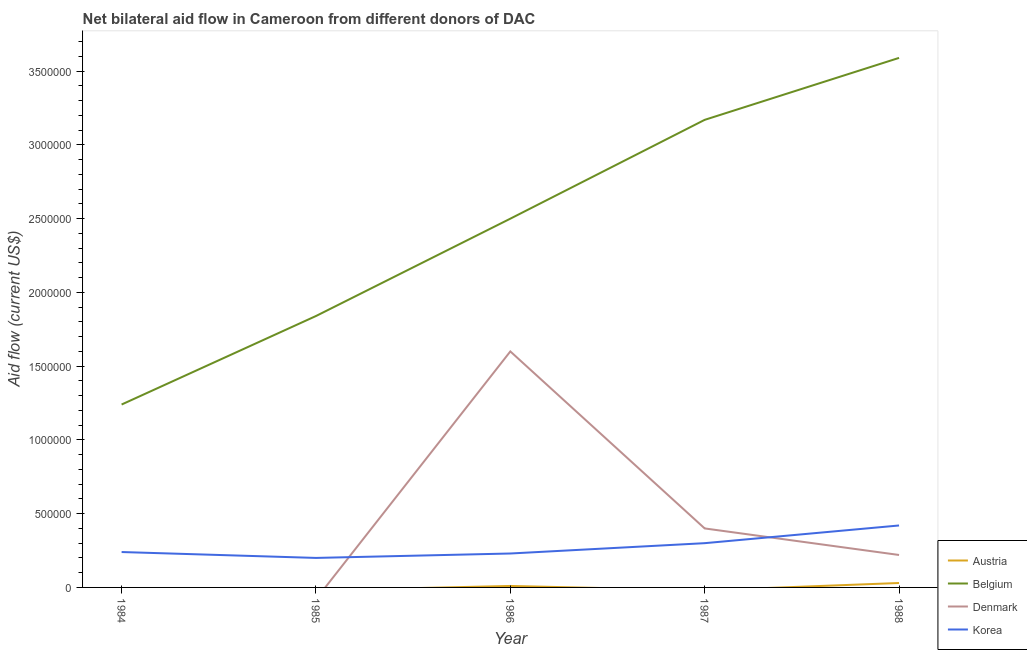Is the number of lines equal to the number of legend labels?
Offer a terse response. No. What is the amount of aid given by korea in 1985?
Your answer should be very brief. 2.00e+05. Across all years, what is the maximum amount of aid given by korea?
Your answer should be very brief. 4.20e+05. Across all years, what is the minimum amount of aid given by austria?
Your answer should be compact. 0. In which year was the amount of aid given by belgium maximum?
Give a very brief answer. 1988. What is the total amount of aid given by korea in the graph?
Your answer should be compact. 1.39e+06. What is the difference between the amount of aid given by korea in 1985 and that in 1986?
Ensure brevity in your answer.  -3.00e+04. What is the difference between the amount of aid given by austria in 1984 and the amount of aid given by denmark in 1988?
Ensure brevity in your answer.  -2.20e+05. What is the average amount of aid given by belgium per year?
Offer a very short reply. 2.47e+06. In the year 1986, what is the difference between the amount of aid given by korea and amount of aid given by austria?
Provide a short and direct response. 2.20e+05. What is the ratio of the amount of aid given by korea in 1986 to that in 1987?
Your answer should be compact. 0.77. Is the amount of aid given by denmark in 1986 less than that in 1987?
Your answer should be compact. No. What is the difference between the highest and the second highest amount of aid given by belgium?
Give a very brief answer. 4.20e+05. What is the difference between the highest and the lowest amount of aid given by korea?
Your response must be concise. 2.20e+05. Is the sum of the amount of aid given by korea in 1984 and 1988 greater than the maximum amount of aid given by austria across all years?
Offer a terse response. Yes. Is it the case that in every year, the sum of the amount of aid given by denmark and amount of aid given by korea is greater than the sum of amount of aid given by austria and amount of aid given by belgium?
Your answer should be compact. No. Does the amount of aid given by belgium monotonically increase over the years?
Offer a terse response. Yes. Is the amount of aid given by austria strictly greater than the amount of aid given by denmark over the years?
Your answer should be compact. No. Is the amount of aid given by austria strictly less than the amount of aid given by denmark over the years?
Your answer should be compact. No. How many years are there in the graph?
Keep it short and to the point. 5. Does the graph contain grids?
Offer a terse response. No. Where does the legend appear in the graph?
Make the answer very short. Bottom right. How many legend labels are there?
Your answer should be compact. 4. How are the legend labels stacked?
Make the answer very short. Vertical. What is the title of the graph?
Offer a terse response. Net bilateral aid flow in Cameroon from different donors of DAC. What is the label or title of the X-axis?
Your response must be concise. Year. What is the label or title of the Y-axis?
Your response must be concise. Aid flow (current US$). What is the Aid flow (current US$) in Austria in 1984?
Your response must be concise. 0. What is the Aid flow (current US$) of Belgium in 1984?
Your answer should be very brief. 1.24e+06. What is the Aid flow (current US$) of Korea in 1984?
Your answer should be very brief. 2.40e+05. What is the Aid flow (current US$) in Austria in 1985?
Your response must be concise. 0. What is the Aid flow (current US$) of Belgium in 1985?
Your answer should be compact. 1.84e+06. What is the Aid flow (current US$) in Austria in 1986?
Make the answer very short. 10000. What is the Aid flow (current US$) in Belgium in 1986?
Your answer should be very brief. 2.50e+06. What is the Aid flow (current US$) in Denmark in 1986?
Provide a succinct answer. 1.60e+06. What is the Aid flow (current US$) in Austria in 1987?
Your answer should be compact. 0. What is the Aid flow (current US$) in Belgium in 1987?
Give a very brief answer. 3.17e+06. What is the Aid flow (current US$) of Denmark in 1987?
Your response must be concise. 4.00e+05. What is the Aid flow (current US$) of Korea in 1987?
Provide a short and direct response. 3.00e+05. What is the Aid flow (current US$) in Austria in 1988?
Provide a succinct answer. 3.00e+04. What is the Aid flow (current US$) of Belgium in 1988?
Your response must be concise. 3.59e+06. What is the Aid flow (current US$) of Denmark in 1988?
Offer a very short reply. 2.20e+05. Across all years, what is the maximum Aid flow (current US$) in Belgium?
Your answer should be compact. 3.59e+06. Across all years, what is the maximum Aid flow (current US$) in Denmark?
Provide a short and direct response. 1.60e+06. Across all years, what is the minimum Aid flow (current US$) in Belgium?
Provide a succinct answer. 1.24e+06. Across all years, what is the minimum Aid flow (current US$) of Denmark?
Your answer should be compact. 0. What is the total Aid flow (current US$) in Belgium in the graph?
Your answer should be very brief. 1.23e+07. What is the total Aid flow (current US$) in Denmark in the graph?
Offer a terse response. 2.22e+06. What is the total Aid flow (current US$) of Korea in the graph?
Give a very brief answer. 1.39e+06. What is the difference between the Aid flow (current US$) of Belgium in 1984 and that in 1985?
Offer a very short reply. -6.00e+05. What is the difference between the Aid flow (current US$) in Belgium in 1984 and that in 1986?
Provide a short and direct response. -1.26e+06. What is the difference between the Aid flow (current US$) in Belgium in 1984 and that in 1987?
Provide a succinct answer. -1.93e+06. What is the difference between the Aid flow (current US$) in Belgium in 1984 and that in 1988?
Your answer should be very brief. -2.35e+06. What is the difference between the Aid flow (current US$) of Belgium in 1985 and that in 1986?
Your answer should be very brief. -6.60e+05. What is the difference between the Aid flow (current US$) of Belgium in 1985 and that in 1987?
Your response must be concise. -1.33e+06. What is the difference between the Aid flow (current US$) in Korea in 1985 and that in 1987?
Offer a very short reply. -1.00e+05. What is the difference between the Aid flow (current US$) in Belgium in 1985 and that in 1988?
Make the answer very short. -1.75e+06. What is the difference between the Aid flow (current US$) in Belgium in 1986 and that in 1987?
Provide a succinct answer. -6.70e+05. What is the difference between the Aid flow (current US$) of Denmark in 1986 and that in 1987?
Your answer should be very brief. 1.20e+06. What is the difference between the Aid flow (current US$) of Korea in 1986 and that in 1987?
Provide a short and direct response. -7.00e+04. What is the difference between the Aid flow (current US$) of Austria in 1986 and that in 1988?
Offer a very short reply. -2.00e+04. What is the difference between the Aid flow (current US$) in Belgium in 1986 and that in 1988?
Offer a terse response. -1.09e+06. What is the difference between the Aid flow (current US$) of Denmark in 1986 and that in 1988?
Ensure brevity in your answer.  1.38e+06. What is the difference between the Aid flow (current US$) in Korea in 1986 and that in 1988?
Offer a very short reply. -1.90e+05. What is the difference between the Aid flow (current US$) in Belgium in 1987 and that in 1988?
Your answer should be compact. -4.20e+05. What is the difference between the Aid flow (current US$) in Denmark in 1987 and that in 1988?
Keep it short and to the point. 1.80e+05. What is the difference between the Aid flow (current US$) in Korea in 1987 and that in 1988?
Your answer should be very brief. -1.20e+05. What is the difference between the Aid flow (current US$) in Belgium in 1984 and the Aid flow (current US$) in Korea in 1985?
Offer a very short reply. 1.04e+06. What is the difference between the Aid flow (current US$) of Belgium in 1984 and the Aid flow (current US$) of Denmark in 1986?
Give a very brief answer. -3.60e+05. What is the difference between the Aid flow (current US$) in Belgium in 1984 and the Aid flow (current US$) in Korea in 1986?
Your answer should be compact. 1.01e+06. What is the difference between the Aid flow (current US$) in Belgium in 1984 and the Aid flow (current US$) in Denmark in 1987?
Provide a succinct answer. 8.40e+05. What is the difference between the Aid flow (current US$) in Belgium in 1984 and the Aid flow (current US$) in Korea in 1987?
Offer a very short reply. 9.40e+05. What is the difference between the Aid flow (current US$) in Belgium in 1984 and the Aid flow (current US$) in Denmark in 1988?
Make the answer very short. 1.02e+06. What is the difference between the Aid flow (current US$) of Belgium in 1984 and the Aid flow (current US$) of Korea in 1988?
Make the answer very short. 8.20e+05. What is the difference between the Aid flow (current US$) of Belgium in 1985 and the Aid flow (current US$) of Denmark in 1986?
Your response must be concise. 2.40e+05. What is the difference between the Aid flow (current US$) of Belgium in 1985 and the Aid flow (current US$) of Korea in 1986?
Your response must be concise. 1.61e+06. What is the difference between the Aid flow (current US$) of Belgium in 1985 and the Aid flow (current US$) of Denmark in 1987?
Make the answer very short. 1.44e+06. What is the difference between the Aid flow (current US$) of Belgium in 1985 and the Aid flow (current US$) of Korea in 1987?
Provide a succinct answer. 1.54e+06. What is the difference between the Aid flow (current US$) in Belgium in 1985 and the Aid flow (current US$) in Denmark in 1988?
Keep it short and to the point. 1.62e+06. What is the difference between the Aid flow (current US$) in Belgium in 1985 and the Aid flow (current US$) in Korea in 1988?
Make the answer very short. 1.42e+06. What is the difference between the Aid flow (current US$) in Austria in 1986 and the Aid flow (current US$) in Belgium in 1987?
Offer a terse response. -3.16e+06. What is the difference between the Aid flow (current US$) of Austria in 1986 and the Aid flow (current US$) of Denmark in 1987?
Keep it short and to the point. -3.90e+05. What is the difference between the Aid flow (current US$) in Belgium in 1986 and the Aid flow (current US$) in Denmark in 1987?
Offer a very short reply. 2.10e+06. What is the difference between the Aid flow (current US$) in Belgium in 1986 and the Aid flow (current US$) in Korea in 1987?
Ensure brevity in your answer.  2.20e+06. What is the difference between the Aid flow (current US$) in Denmark in 1986 and the Aid flow (current US$) in Korea in 1987?
Provide a succinct answer. 1.30e+06. What is the difference between the Aid flow (current US$) in Austria in 1986 and the Aid flow (current US$) in Belgium in 1988?
Offer a very short reply. -3.58e+06. What is the difference between the Aid flow (current US$) in Austria in 1986 and the Aid flow (current US$) in Denmark in 1988?
Your answer should be compact. -2.10e+05. What is the difference between the Aid flow (current US$) in Austria in 1986 and the Aid flow (current US$) in Korea in 1988?
Offer a terse response. -4.10e+05. What is the difference between the Aid flow (current US$) of Belgium in 1986 and the Aid flow (current US$) of Denmark in 1988?
Your answer should be very brief. 2.28e+06. What is the difference between the Aid flow (current US$) of Belgium in 1986 and the Aid flow (current US$) of Korea in 1988?
Give a very brief answer. 2.08e+06. What is the difference between the Aid flow (current US$) of Denmark in 1986 and the Aid flow (current US$) of Korea in 1988?
Your answer should be compact. 1.18e+06. What is the difference between the Aid flow (current US$) in Belgium in 1987 and the Aid flow (current US$) in Denmark in 1988?
Your response must be concise. 2.95e+06. What is the difference between the Aid flow (current US$) in Belgium in 1987 and the Aid flow (current US$) in Korea in 1988?
Provide a succinct answer. 2.75e+06. What is the difference between the Aid flow (current US$) in Denmark in 1987 and the Aid flow (current US$) in Korea in 1988?
Provide a succinct answer. -2.00e+04. What is the average Aid flow (current US$) in Austria per year?
Your response must be concise. 8000. What is the average Aid flow (current US$) in Belgium per year?
Your response must be concise. 2.47e+06. What is the average Aid flow (current US$) of Denmark per year?
Your answer should be compact. 4.44e+05. What is the average Aid flow (current US$) in Korea per year?
Make the answer very short. 2.78e+05. In the year 1984, what is the difference between the Aid flow (current US$) in Belgium and Aid flow (current US$) in Korea?
Make the answer very short. 1.00e+06. In the year 1985, what is the difference between the Aid flow (current US$) in Belgium and Aid flow (current US$) in Korea?
Ensure brevity in your answer.  1.64e+06. In the year 1986, what is the difference between the Aid flow (current US$) in Austria and Aid flow (current US$) in Belgium?
Your response must be concise. -2.49e+06. In the year 1986, what is the difference between the Aid flow (current US$) in Austria and Aid flow (current US$) in Denmark?
Your answer should be very brief. -1.59e+06. In the year 1986, what is the difference between the Aid flow (current US$) of Belgium and Aid flow (current US$) of Korea?
Your answer should be very brief. 2.27e+06. In the year 1986, what is the difference between the Aid flow (current US$) of Denmark and Aid flow (current US$) of Korea?
Your answer should be very brief. 1.37e+06. In the year 1987, what is the difference between the Aid flow (current US$) of Belgium and Aid flow (current US$) of Denmark?
Your answer should be very brief. 2.77e+06. In the year 1987, what is the difference between the Aid flow (current US$) in Belgium and Aid flow (current US$) in Korea?
Give a very brief answer. 2.87e+06. In the year 1988, what is the difference between the Aid flow (current US$) in Austria and Aid flow (current US$) in Belgium?
Keep it short and to the point. -3.56e+06. In the year 1988, what is the difference between the Aid flow (current US$) of Austria and Aid flow (current US$) of Denmark?
Your answer should be very brief. -1.90e+05. In the year 1988, what is the difference between the Aid flow (current US$) in Austria and Aid flow (current US$) in Korea?
Make the answer very short. -3.90e+05. In the year 1988, what is the difference between the Aid flow (current US$) of Belgium and Aid flow (current US$) of Denmark?
Your answer should be compact. 3.37e+06. In the year 1988, what is the difference between the Aid flow (current US$) in Belgium and Aid flow (current US$) in Korea?
Give a very brief answer. 3.17e+06. In the year 1988, what is the difference between the Aid flow (current US$) of Denmark and Aid flow (current US$) of Korea?
Give a very brief answer. -2.00e+05. What is the ratio of the Aid flow (current US$) in Belgium in 1984 to that in 1985?
Give a very brief answer. 0.67. What is the ratio of the Aid flow (current US$) in Korea in 1984 to that in 1985?
Give a very brief answer. 1.2. What is the ratio of the Aid flow (current US$) in Belgium in 1984 to that in 1986?
Offer a very short reply. 0.5. What is the ratio of the Aid flow (current US$) of Korea in 1984 to that in 1986?
Your response must be concise. 1.04. What is the ratio of the Aid flow (current US$) of Belgium in 1984 to that in 1987?
Offer a very short reply. 0.39. What is the ratio of the Aid flow (current US$) of Belgium in 1984 to that in 1988?
Provide a succinct answer. 0.35. What is the ratio of the Aid flow (current US$) of Korea in 1984 to that in 1988?
Provide a succinct answer. 0.57. What is the ratio of the Aid flow (current US$) in Belgium in 1985 to that in 1986?
Keep it short and to the point. 0.74. What is the ratio of the Aid flow (current US$) in Korea in 1985 to that in 1986?
Provide a succinct answer. 0.87. What is the ratio of the Aid flow (current US$) of Belgium in 1985 to that in 1987?
Make the answer very short. 0.58. What is the ratio of the Aid flow (current US$) of Belgium in 1985 to that in 1988?
Keep it short and to the point. 0.51. What is the ratio of the Aid flow (current US$) of Korea in 1985 to that in 1988?
Keep it short and to the point. 0.48. What is the ratio of the Aid flow (current US$) in Belgium in 1986 to that in 1987?
Ensure brevity in your answer.  0.79. What is the ratio of the Aid flow (current US$) in Korea in 1986 to that in 1987?
Give a very brief answer. 0.77. What is the ratio of the Aid flow (current US$) of Austria in 1986 to that in 1988?
Your answer should be very brief. 0.33. What is the ratio of the Aid flow (current US$) of Belgium in 1986 to that in 1988?
Your response must be concise. 0.7. What is the ratio of the Aid flow (current US$) in Denmark in 1986 to that in 1988?
Give a very brief answer. 7.27. What is the ratio of the Aid flow (current US$) in Korea in 1986 to that in 1988?
Ensure brevity in your answer.  0.55. What is the ratio of the Aid flow (current US$) of Belgium in 1987 to that in 1988?
Provide a succinct answer. 0.88. What is the ratio of the Aid flow (current US$) in Denmark in 1987 to that in 1988?
Give a very brief answer. 1.82. What is the difference between the highest and the second highest Aid flow (current US$) in Denmark?
Keep it short and to the point. 1.20e+06. What is the difference between the highest and the lowest Aid flow (current US$) in Austria?
Offer a very short reply. 3.00e+04. What is the difference between the highest and the lowest Aid flow (current US$) of Belgium?
Your answer should be very brief. 2.35e+06. What is the difference between the highest and the lowest Aid flow (current US$) in Denmark?
Your response must be concise. 1.60e+06. 